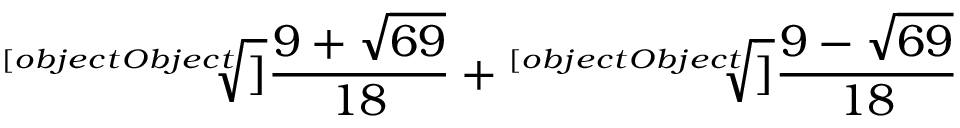<formula> <loc_0><loc_0><loc_500><loc_500>{ \sqrt { [ } [ o b j e c t O b j e c t ] ] { \frac { 9 + { \sqrt { 6 9 } } } { 1 8 } } } + { \sqrt { [ } [ o b j e c t O b j e c t ] ] { \frac { 9 - { \sqrt { 6 9 } } } { 1 8 } } }</formula> 